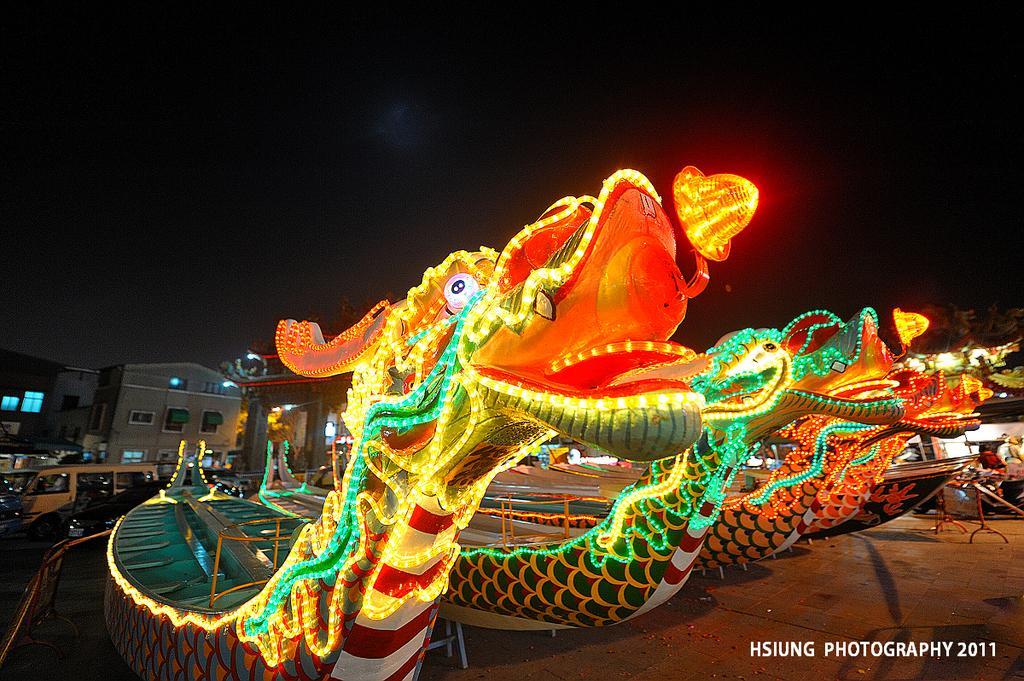In one or two sentences, can you explain what this image depicts? In this picture we can see boat with lights on a platform, here we can see people, buildings, vehicles and some objects and in the background we can see it is dark, in the bottom right we can see some text some text on it. 